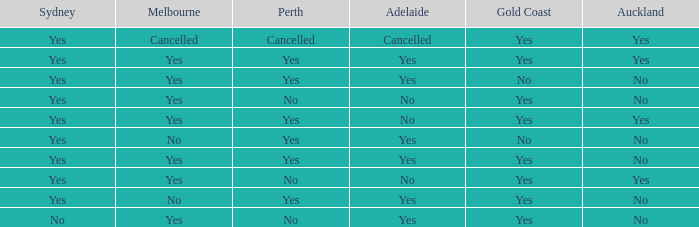What is the sydney that has adelaide, gold coast, melbourne, and auckland are all yes? Yes. Parse the table in full. {'header': ['Sydney', 'Melbourne', 'Perth', 'Adelaide', 'Gold Coast', 'Auckland'], 'rows': [['Yes', 'Cancelled', 'Cancelled', 'Cancelled', 'Yes', 'Yes'], ['Yes', 'Yes', 'Yes', 'Yes', 'Yes', 'Yes'], ['Yes', 'Yes', 'Yes', 'Yes', 'No', 'No'], ['Yes', 'Yes', 'No', 'No', 'Yes', 'No'], ['Yes', 'Yes', 'Yes', 'No', 'Yes', 'Yes'], ['Yes', 'No', 'Yes', 'Yes', 'No', 'No'], ['Yes', 'Yes', 'Yes', 'Yes', 'Yes', 'No'], ['Yes', 'Yes', 'No', 'No', 'Yes', 'Yes'], ['Yes', 'No', 'Yes', 'Yes', 'Yes', 'No'], ['No', 'Yes', 'No', 'Yes', 'Yes', 'No']]} 